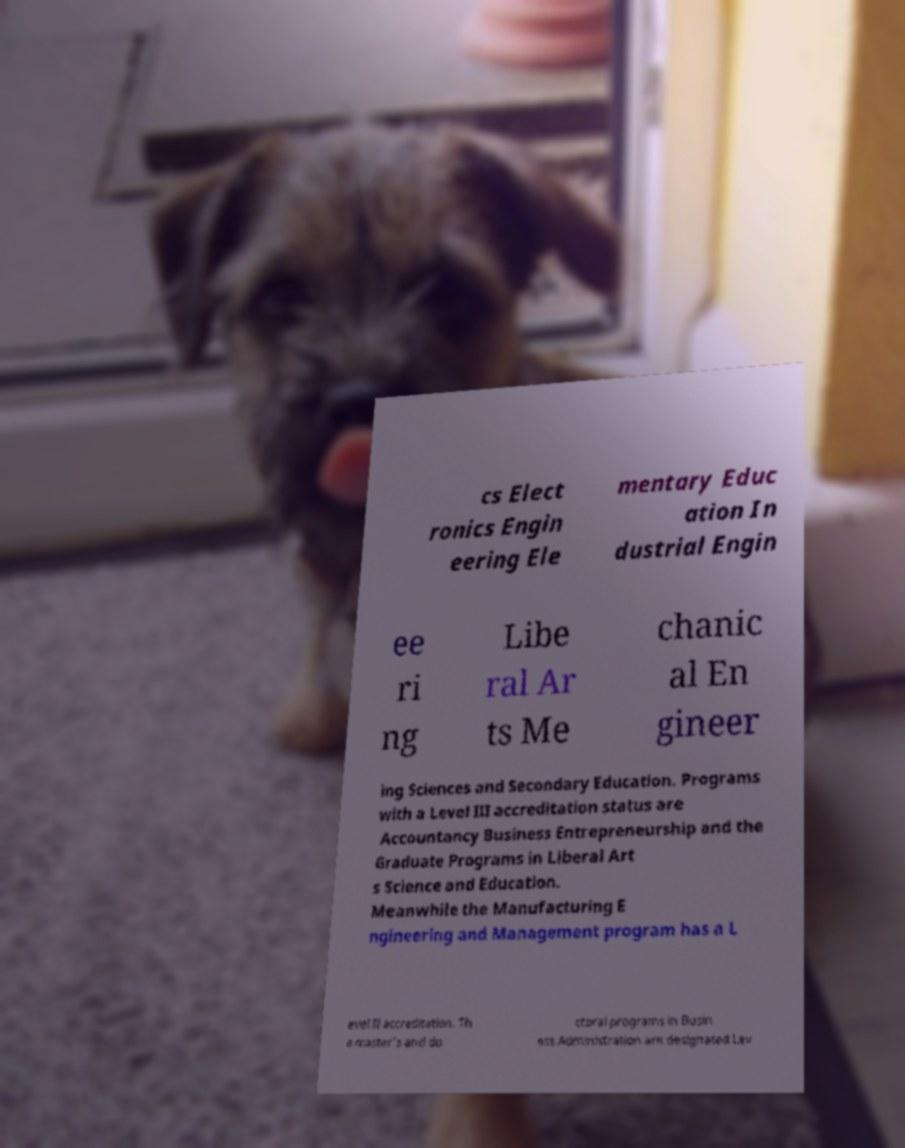There's text embedded in this image that I need extracted. Can you transcribe it verbatim? cs Elect ronics Engin eering Ele mentary Educ ation In dustrial Engin ee ri ng Libe ral Ar ts Me chanic al En gineer ing Sciences and Secondary Education. Programs with a Level III accreditation status are Accountancy Business Entrepreneurship and the Graduate Programs in Liberal Art s Science and Education. Meanwhile the Manufacturing E ngineering and Management program has a L evel II accreditation. Th e master's and do ctoral programs in Busin ess Administration are designated Lev 